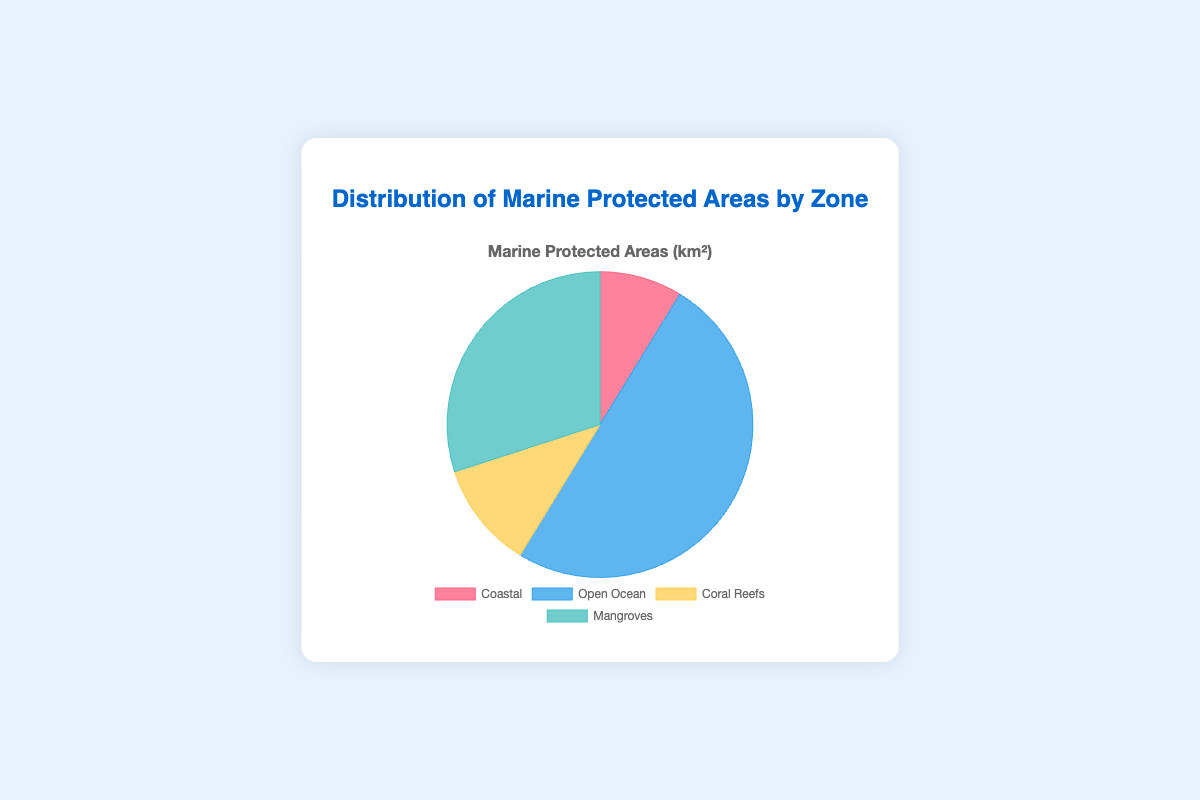What's the largest zone of Marine Protected Areas in the figure? By visual inspection of the pie chart, we can see the segment with the largest area. As indicated by the colors and sizes, the "Open Ocean" takes up the largest portion of the chart.
Answer: Open Ocean Which two zones have similar sizes of Marine Protected Areas? By comparing the visual sizes of the segments, "Coral Reefs" and "Coastal" have relatively similar sizes compared to the other segments.
Answer: Coral Reefs and Coastal Which zone is represented by the yellow segment? By looking at the color legend in the pie chart, the yellow segment corresponds to the "Coral Reefs" zone.
Answer: Coral Reefs What is the total number of square kilometers for Marine Protected Areas shown in the pie chart? The total number of square kilometers is calculated by summing up all the values of the zones. The values provided in the dataset are Coastal (35), Open Ocean (200), Coral Reefs (45), and Mangroves (120). So, 35 + 200 + 45 + 120 = 400 km².
Answer: 400 km² How does the size of the Mangroves zone compare to the Coastal zone? By observing the areas of the segments, the Mangroves segment is larger than the Coastal segment. The visual proportion of the Mangroves segment occupies a larger part of the chart.
Answer: Mangroves is larger than Coastal What color represents the Open Ocean zone? By referring to the pie chart color legend, the color representing the Open Ocean zone is blue.
Answer: Blue What is the sum of the areas for the Coastal and Coral Reefs zones? Adding the areas of the Coastal and Coral Reefs zones from the provided data: 35 (Coastal) + 45 (Coral Reefs) = 80 km².
Answer: 80 km² If the total area was split equally among the four zones, what would be the area per zone? The total area of 400 km² divided by the 4 zones results in 400 / 4 = 100 km² per zone.
Answer: 100 km² Which segment is smaller: Coral Reefs or Mangroves? By comparing the sizes of the segments, the Coral Reefs segment is smaller than the Mangroves segment.
Answer: Coral Reefs 